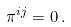Convert formula to latex. <formula><loc_0><loc_0><loc_500><loc_500>\pi ^ { i j } = 0 \, .</formula> 